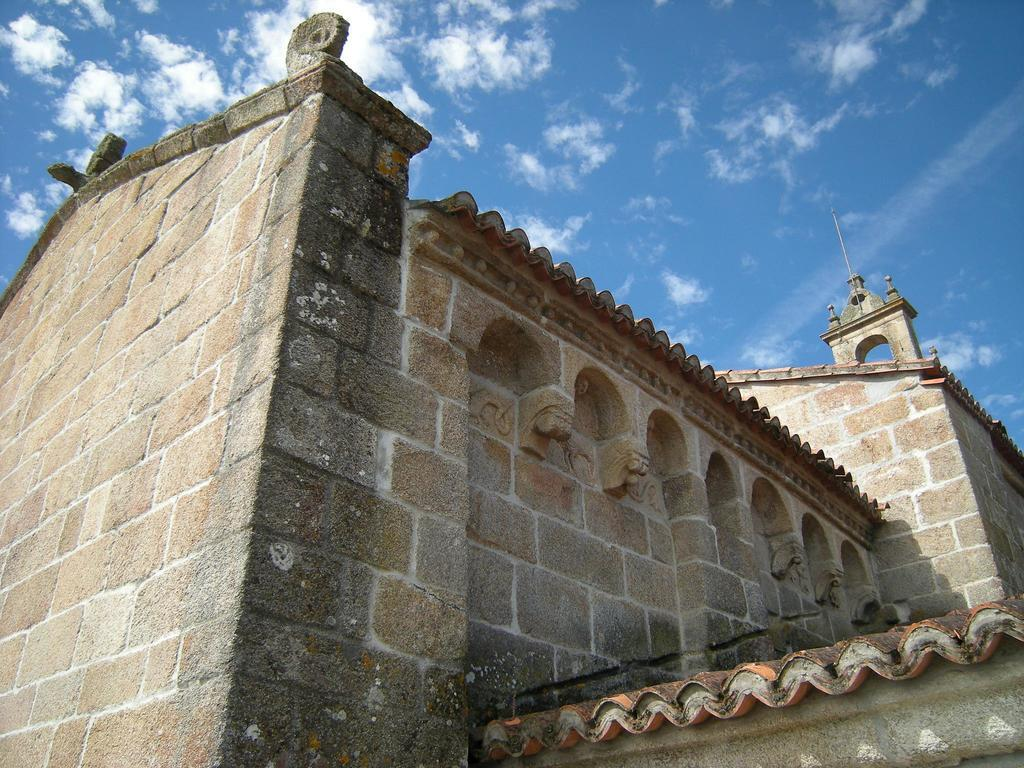What is the main structure in the center of the image? There is a fort in the center of the image. What is the condition of the sky in the image? The sky is cloudy in the image. What is the level of wealth of the kitten playing in the recess of the fort in the image? There is no kitten or recess present in the image, so we cannot determine the level of wealth of a kitten. 